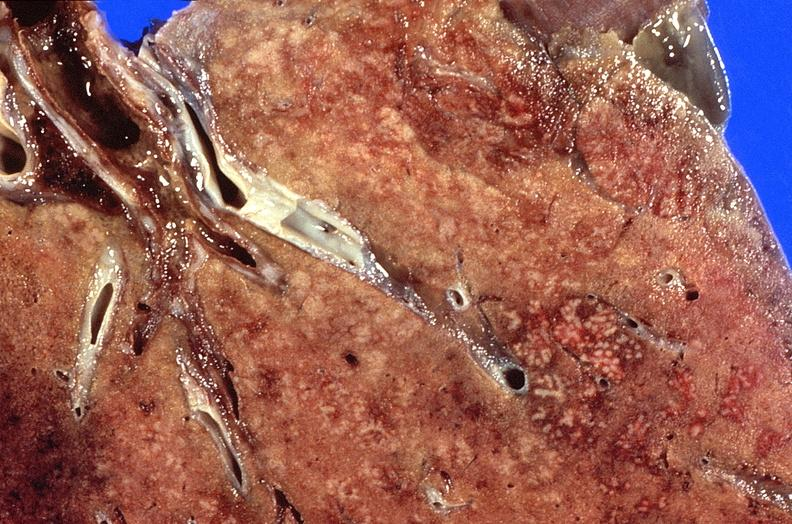where is this?
Answer the question using a single word or phrase. Lung 